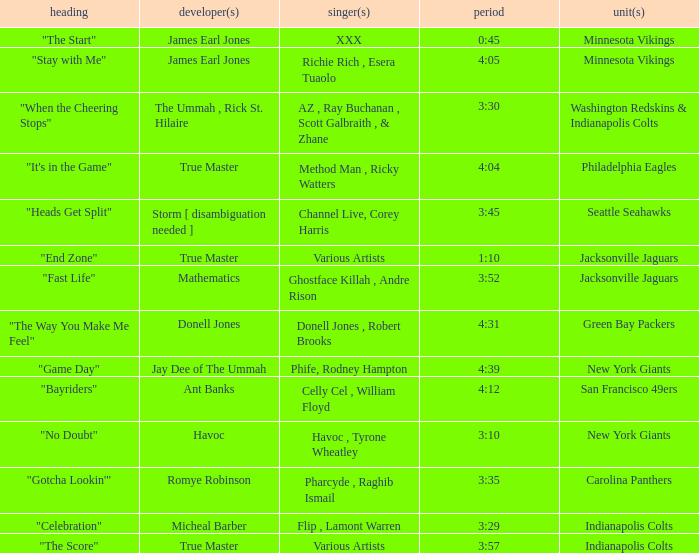How long is the XXX track used by the Minnesota Vikings? 0:45. 